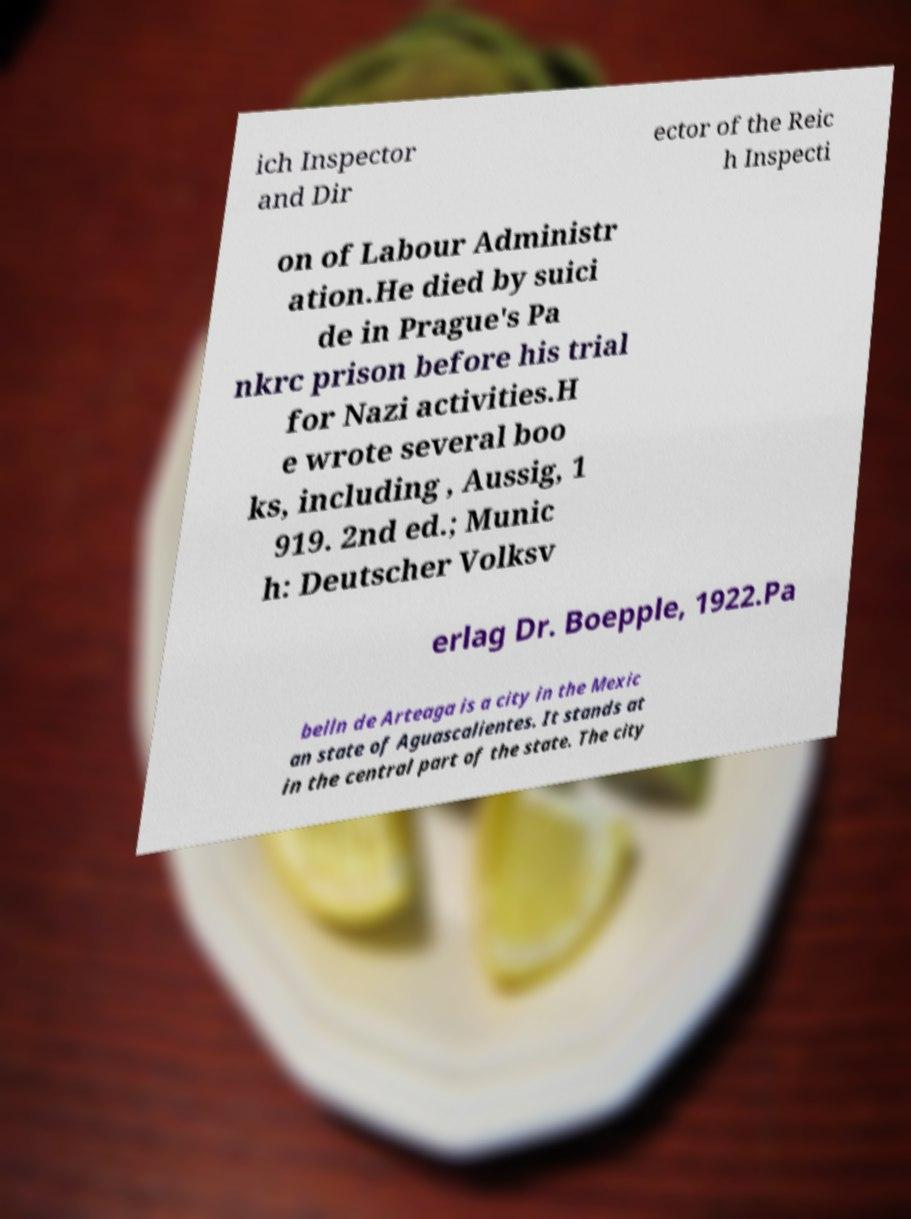For documentation purposes, I need the text within this image transcribed. Could you provide that? ich Inspector and Dir ector of the Reic h Inspecti on of Labour Administr ation.He died by suici de in Prague's Pa nkrc prison before his trial for Nazi activities.H e wrote several boo ks, including , Aussig, 1 919. 2nd ed.; Munic h: Deutscher Volksv erlag Dr. Boepple, 1922.Pa belln de Arteaga is a city in the Mexic an state of Aguascalientes. It stands at in the central part of the state. The city 